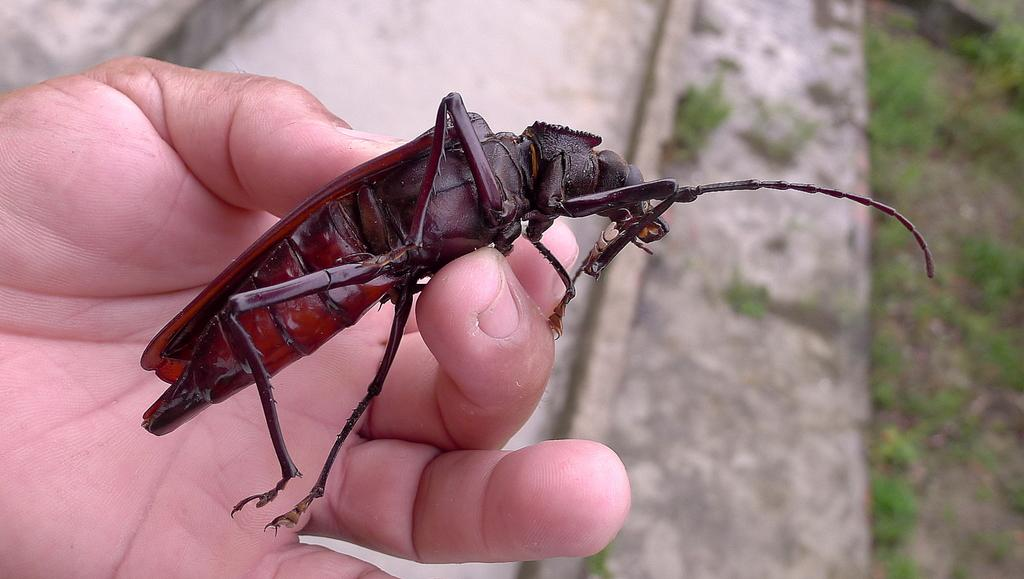What is the person in the image holding? The person is holding an insect in the image. What can be seen in the background of the image? There is land visible in the background of the image, and there is also grass present. What type of drink is the person holding in the image? There is no drink visible in the image; the person is holding an insect. 